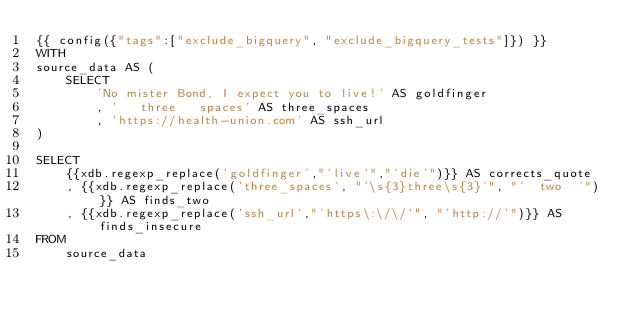Convert code to text. <code><loc_0><loc_0><loc_500><loc_500><_SQL_>{{ config({"tags":["exclude_bigquery", "exclude_bigquery_tests"]}) }}
WITH
source_data AS (
    SELECT
        'No mister Bond, I expect you to live!' AS goldfinger
        , '   three   spaces' AS three_spaces
        , 'https://health-union.com' AS ssh_url
)

SELECT
    {{xdb.regexp_replace('goldfinger',"'live'","'die'")}} AS corrects_quote
    , {{xdb.regexp_replace('three_spaces', "'\s{3}three\s{3}'", "'  two  '")}} AS finds_two
    , {{xdb.regexp_replace('ssh_url',"'https\:\/\/'", "'http://'")}} AS finds_insecure
FROM
    source_data
</code> 